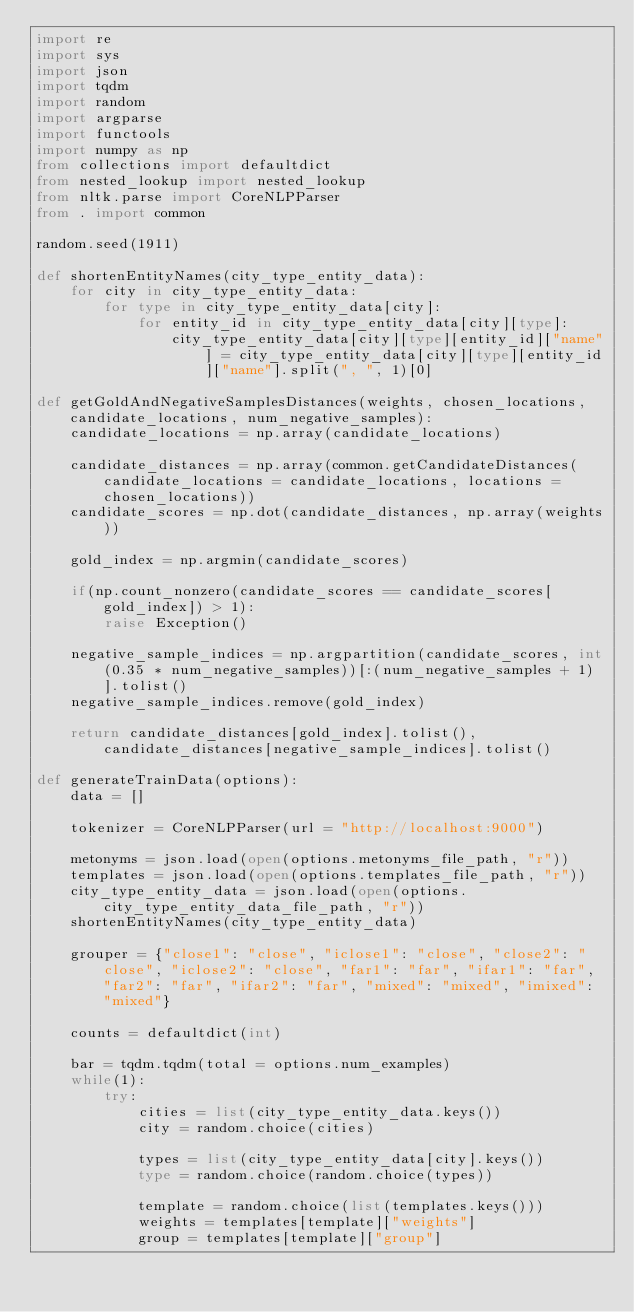Convert code to text. <code><loc_0><loc_0><loc_500><loc_500><_Python_>import re
import sys
import json
import tqdm
import random
import argparse
import functools
import numpy as np
from collections import defaultdict
from nested_lookup import nested_lookup
from nltk.parse import CoreNLPParser
from . import common

random.seed(1911)

def shortenEntityNames(city_type_entity_data):
    for city in city_type_entity_data:
        for type in city_type_entity_data[city]:
            for entity_id in city_type_entity_data[city][type]:
                city_type_entity_data[city][type][entity_id]["name"] = city_type_entity_data[city][type][entity_id]["name"].split(", ", 1)[0]

def getGoldAndNegativeSamplesDistances(weights, chosen_locations, candidate_locations, num_negative_samples):
    candidate_locations = np.array(candidate_locations)

    candidate_distances = np.array(common.getCandidateDistances(candidate_locations = candidate_locations, locations = chosen_locations))
    candidate_scores = np.dot(candidate_distances, np.array(weights))

    gold_index = np.argmin(candidate_scores)

    if(np.count_nonzero(candidate_scores == candidate_scores[gold_index]) > 1):
        raise Exception()

    negative_sample_indices = np.argpartition(candidate_scores, int(0.35 * num_negative_samples))[:(num_negative_samples + 1)].tolist()
    negative_sample_indices.remove(gold_index)

    return candidate_distances[gold_index].tolist(), candidate_distances[negative_sample_indices].tolist()

def generateTrainData(options):
    data = []

    tokenizer = CoreNLPParser(url = "http://localhost:9000")

    metonyms = json.load(open(options.metonyms_file_path, "r"))
    templates = json.load(open(options.templates_file_path, "r"))
    city_type_entity_data = json.load(open(options.city_type_entity_data_file_path, "r"))
    shortenEntityNames(city_type_entity_data)

    grouper = {"close1": "close", "iclose1": "close", "close2": "close", "iclose2": "close", "far1": "far", "ifar1": "far", "far2": "far", "ifar2": "far", "mixed": "mixed", "imixed": "mixed"}

    counts = defaultdict(int)

    bar = tqdm.tqdm(total = options.num_examples)
    while(1):
        try:
            cities = list(city_type_entity_data.keys())
            city = random.choice(cities)

            types = list(city_type_entity_data[city].keys())
            type = random.choice(random.choice(types))

            template = random.choice(list(templates.keys()))
            weights = templates[template]["weights"]
            group = templates[template]["group"]
</code> 